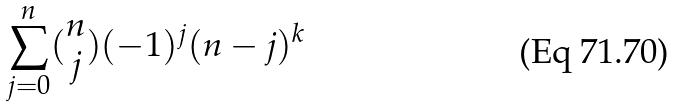Convert formula to latex. <formula><loc_0><loc_0><loc_500><loc_500>\sum _ { j = 0 } ^ { n } ( \begin{matrix} n \\ j \end{matrix} ) ( - 1 ) ^ { j } ( n - j ) ^ { k }</formula> 